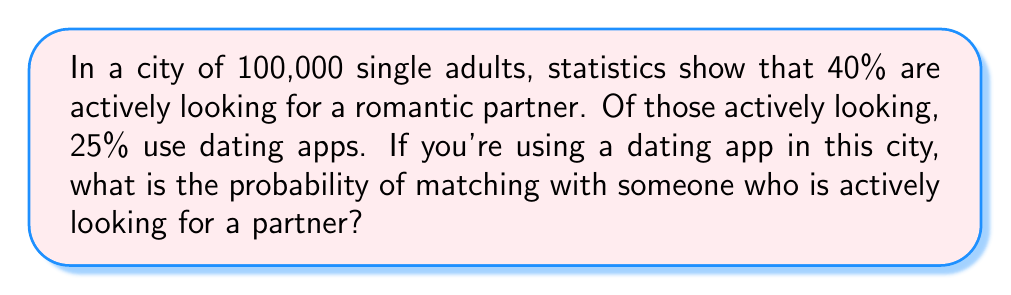Could you help me with this problem? Let's break this down step-by-step:

1. Calculate the number of single adults actively looking for a partner:
   $40\% \text{ of } 100,000 = 0.40 \times 100,000 = 40,000$

2. Calculate the number of people using dating apps:
   $25\% \text{ of } 40,000 = 0.25 \times 40,000 = 10,000$

3. The probability of matching with someone actively looking for a partner is the ratio of people using dating apps who are actively looking to the total number of single adults:

   $$P(\text{matching with someone actively looking}) = \frac{\text{People using dating apps}}{\text{Total single adults}}$$

   $$P(\text{matching with someone actively looking}) = \frac{10,000}{100,000} = \frac{1}{10} = 0.1$$

4. Convert the decimal to a percentage:
   $0.1 \times 100\% = 10\%$

Therefore, the probability of matching with someone who is actively looking for a partner is 10% or 0.1.
Answer: 10% or 0.1 